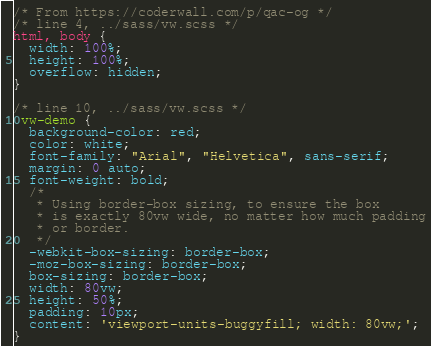Convert code to text. <code><loc_0><loc_0><loc_500><loc_500><_CSS_>/* From https://coderwall.com/p/qac-og */
/* line 4, ../sass/vw.scss */
html, body {
  width: 100%;
  height: 100%;
  overflow: hidden;
}

/* line 10, ../sass/vw.scss */
.vw-demo {
  background-color: red;
  color: white;
  font-family: "Arial", "Helvetica", sans-serif;
  margin: 0 auto;
  font-weight: bold;
  /*
   * Using border-box sizing, to ensure the box
   * is exactly 80vw wide, no matter how much padding
   * or border.
   */
  -webkit-box-sizing: border-box;
  -moz-box-sizing: border-box;
  box-sizing: border-box;
  width: 80vw;
  height: 50%;
  padding: 10px;
  content: 'viewport-units-buggyfill; width: 80vw;';
}
</code> 